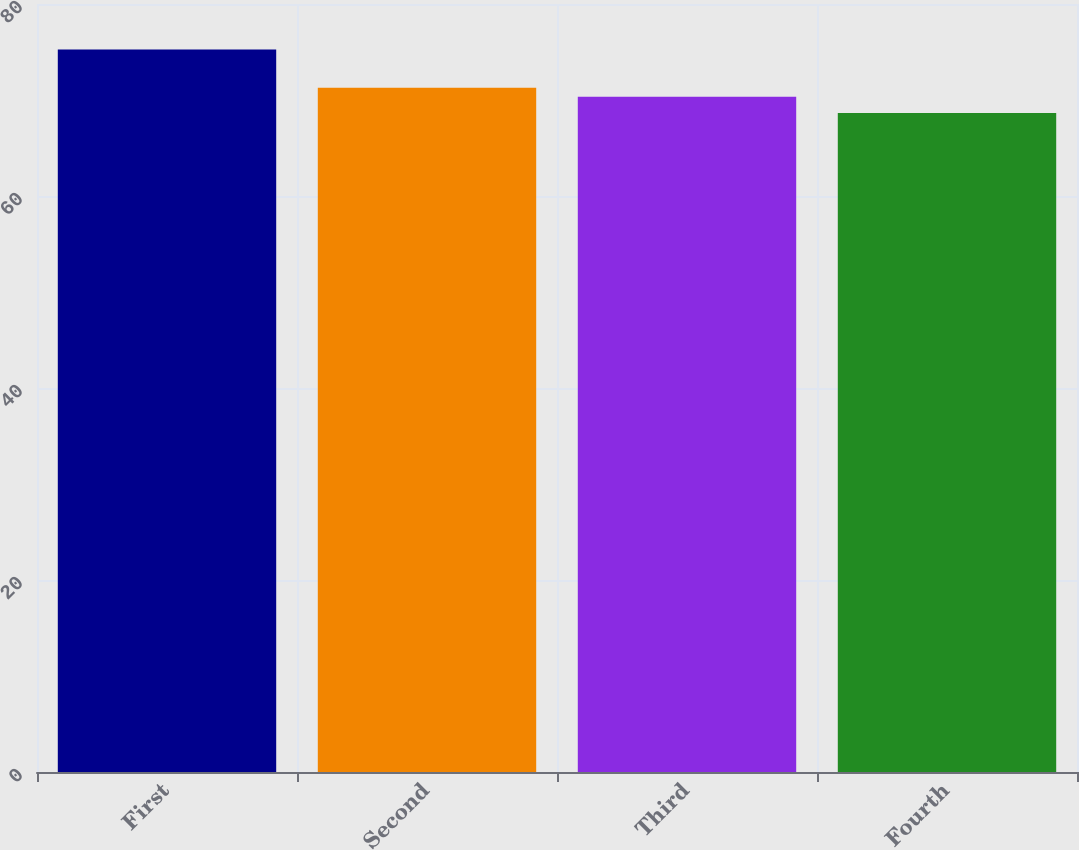Convert chart. <chart><loc_0><loc_0><loc_500><loc_500><bar_chart><fcel>First<fcel>Second<fcel>Third<fcel>Fourth<nl><fcel>75.25<fcel>71.28<fcel>70.35<fcel>68.65<nl></chart> 